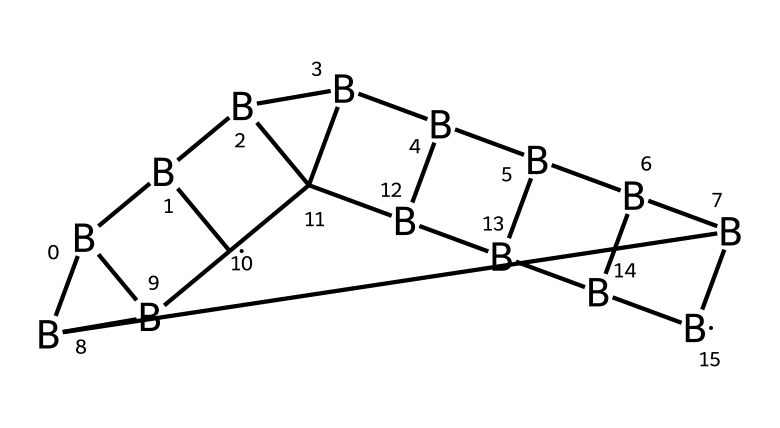What is the total number of boron atoms in the structure? Analyzing the SMILES representation, we can identify the occurrences of the letter "B" which indicates boron atoms present in the structure. The total count reveals there are 12 boron atoms.
Answer: 12 How many carbon atoms are present in the chemical? In the provided SMILES, the letter "C" designates carbon atoms. By counting the instances of "C," we determine that there are 4 carbon atoms in this structure.
Answer: 4 What type of bonding is predominant in carboranes? Carboranes exhibit network covalent bonding due to the interconnected boron and carbon atoms. The structure reinforces the idea of covalent interactions predominating in this compound.
Answer: covalent What is the molecular formula for this compound? By counting the number of boron and carbon atoms from the SMILES, we can compile the total count into a molecular formula. Since there are 12 boron atoms and 4 carbon atoms, the formula becomes C4B12.
Answer: C4B12 How does the structure of carboranes affect thermal stability? Carboranes possess a highly symmetrical structure with strong B-C bonds, which contribute significantly to their thermal stability. The presence of boron clusters enhances this stability compared to simpler boranes.
Answer: enhances stability What characteristic of carboranes allows them to be candidates for space suit materials? The arrangement of boron and carbon creates a material that has strong mechanical properties and thermal stability, making them suitable for demanding conditions of space.
Answer: strong mechanical properties 